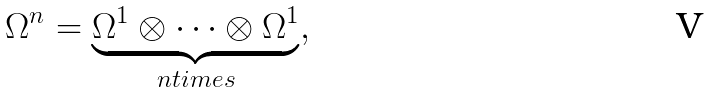Convert formula to latex. <formula><loc_0><loc_0><loc_500><loc_500>\Omega ^ { n } = \underbrace { \Omega ^ { 1 } \otimes \cdots \otimes \Omega ^ { 1 } } _ { n t i m e s } ,</formula> 